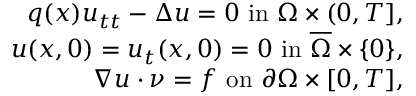Convert formula to latex. <formula><loc_0><loc_0><loc_500><loc_500>\begin{array} { r l r } & { q ( x ) u _ { t t } - \Delta { u } = 0 i n \Omega \times ( 0 , T ] , } \\ & { u ( x , 0 ) = u _ { t } ( x , 0 ) = 0 i n \overline { \Omega } \times \{ 0 \} , } \\ & { \nabla { u } \cdot \nu = f o n \partial \Omega \times [ 0 , T ] , } \end{array}</formula> 